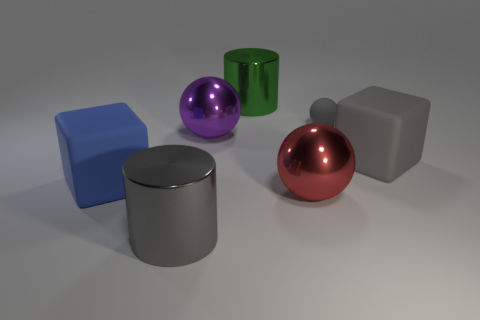Is the color of the large matte object that is to the right of the gray shiny cylinder the same as the large cylinder that is in front of the big gray block? Yes, the color appears to be the same. Both the large matte object to the right of the gray shiny cylinder and the large cylinder in front of the big gray block exhibit a similar hue of purple or violet, sharing a common color but different surface finishes—one being matte and the other having a metallic sheen. 